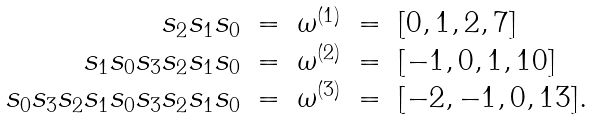<formula> <loc_0><loc_0><loc_500><loc_500>\begin{array} { r c c c l } s _ { 2 } s _ { 1 } s _ { 0 } & = & \omega ^ { ( 1 ) } & = & [ 0 , 1 , 2 , 7 ] \\ s _ { 1 } s _ { 0 } s _ { 3 } s _ { 2 } s _ { 1 } s _ { 0 } & = & \omega ^ { ( 2 ) } & = & [ - 1 , 0 , 1 , 1 0 ] \\ s _ { 0 } s _ { 3 } s _ { 2 } s _ { 1 } s _ { 0 } s _ { 3 } s _ { 2 } s _ { 1 } s _ { 0 } & = & \omega ^ { ( 3 ) } & = & [ - 2 , - 1 , 0 , 1 3 ] . \end{array}</formula> 